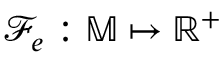Convert formula to latex. <formula><loc_0><loc_0><loc_500><loc_500>\mathcal { F } _ { e } \colon \mathbb { M } \mapsto \mathbb { R } ^ { + }</formula> 